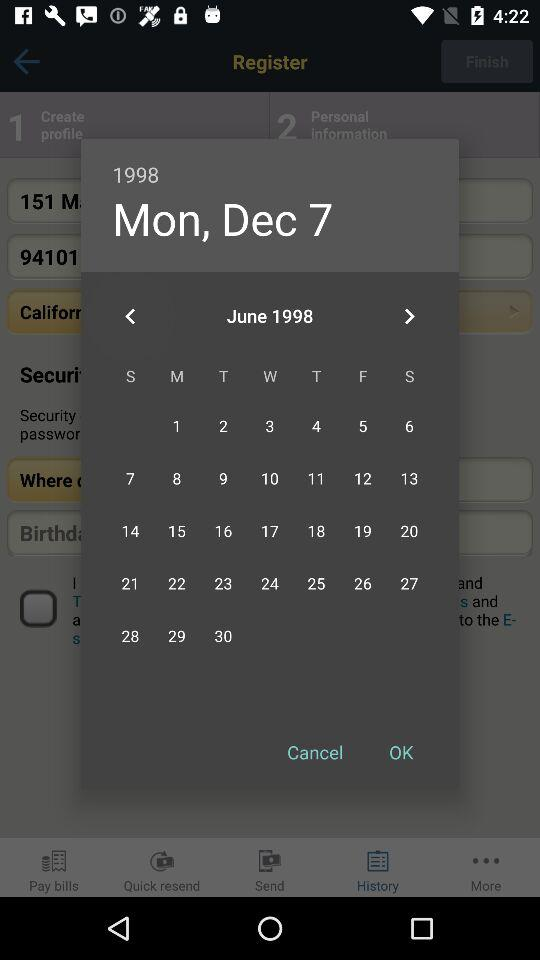What was the day on December 7th, 1998? The day was Monday. 